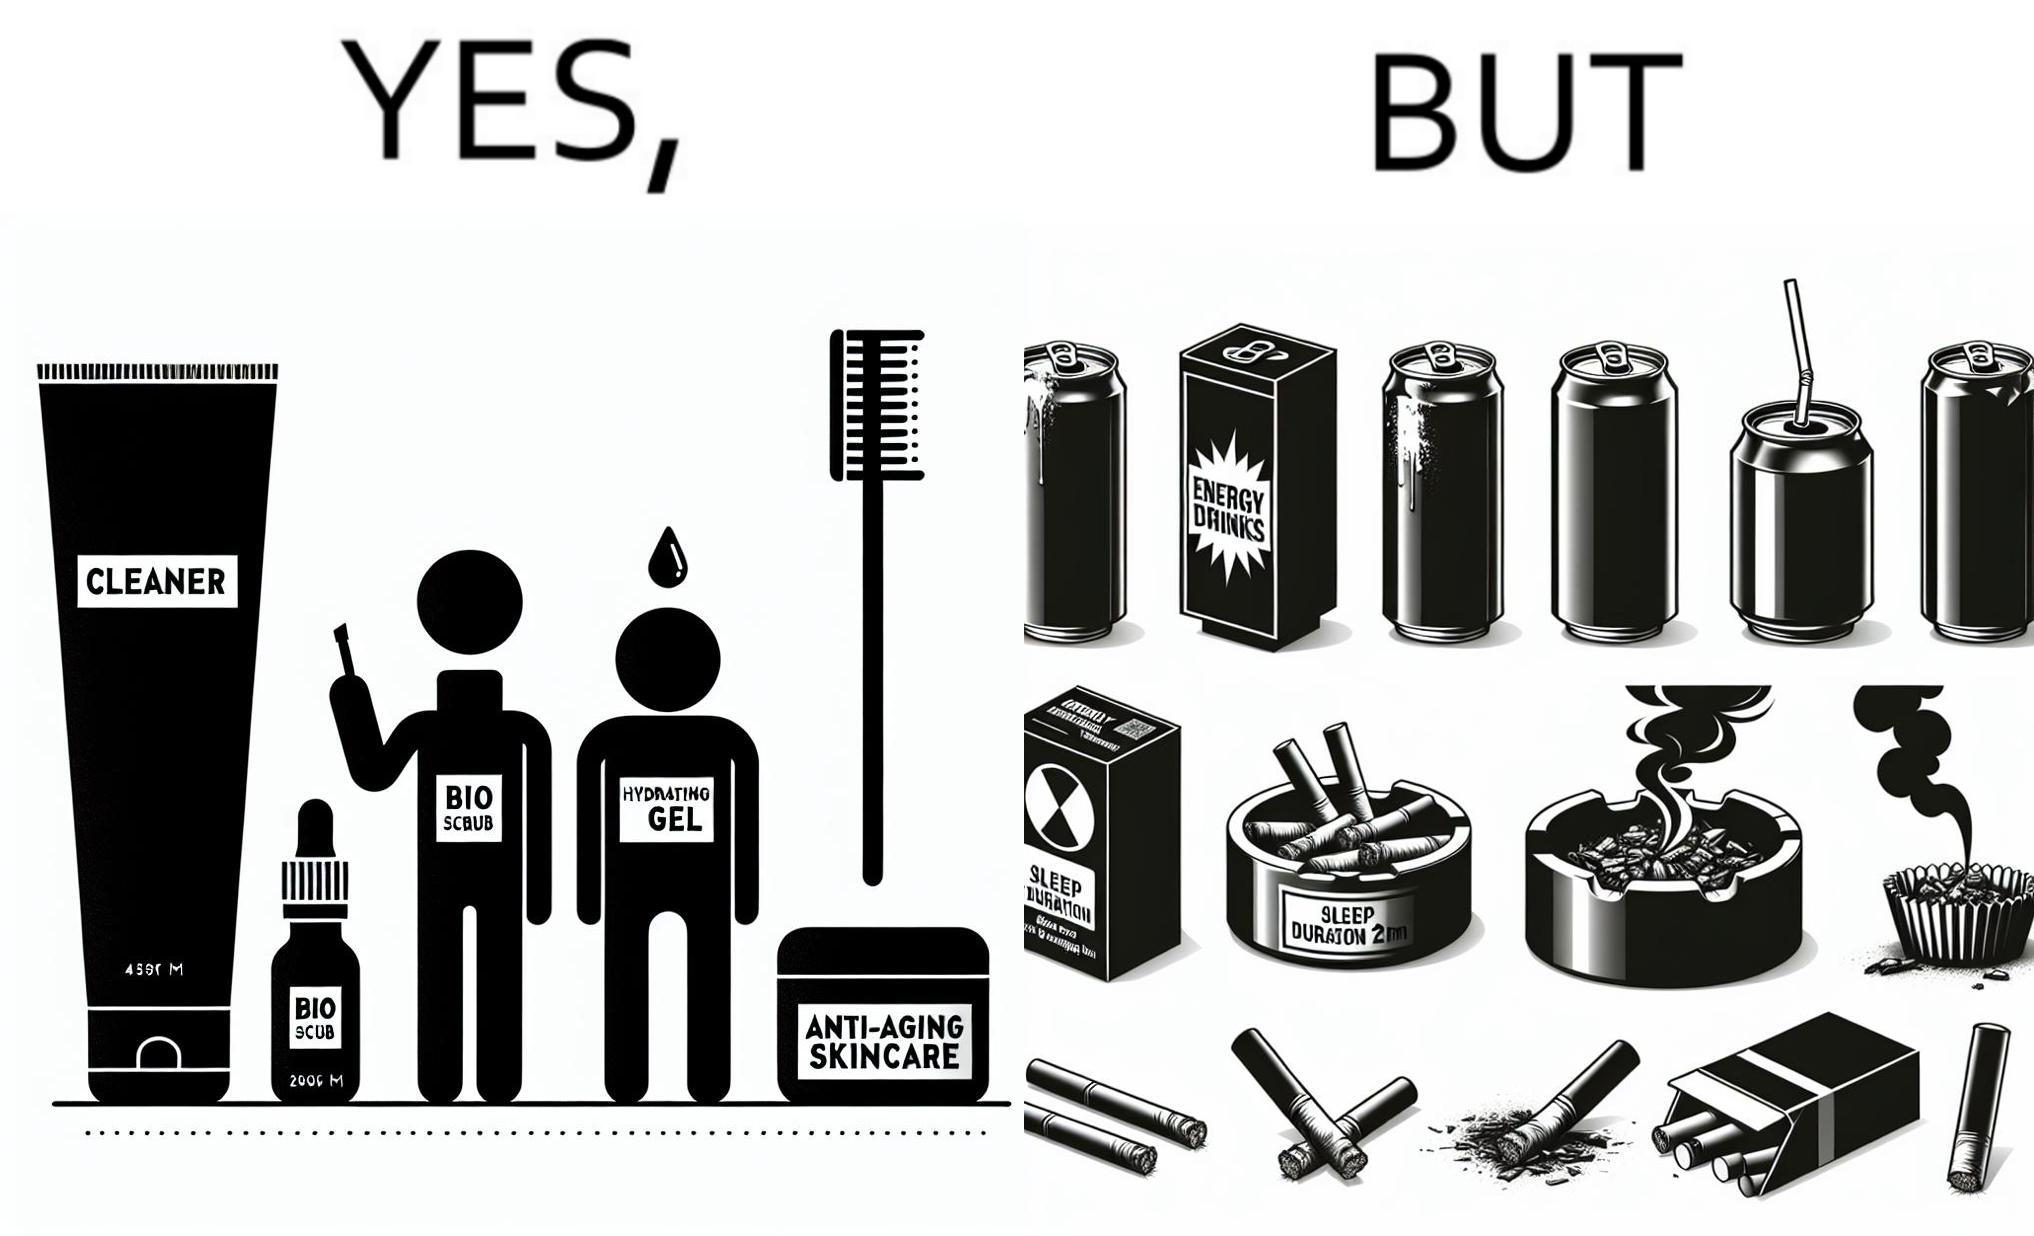Does this image contain satire or humor? Yes, this image is satirical. 